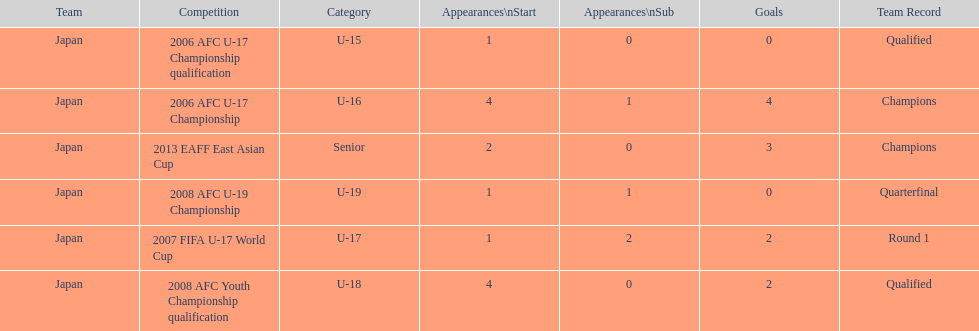Did japan have more starting appearances in the 2013 eaff east asian cup or 2007 fifa u-17 world cup? 2013 EAFF East Asian Cup. 